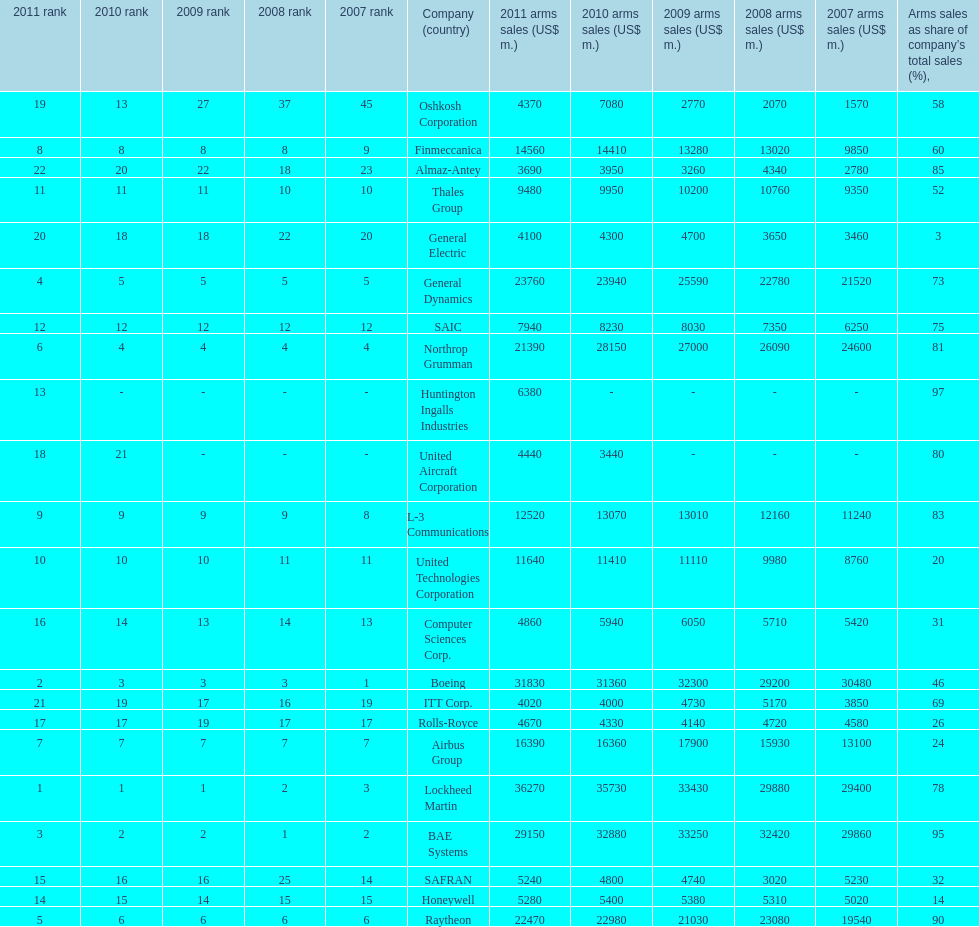What country is the first listed country? USA. 